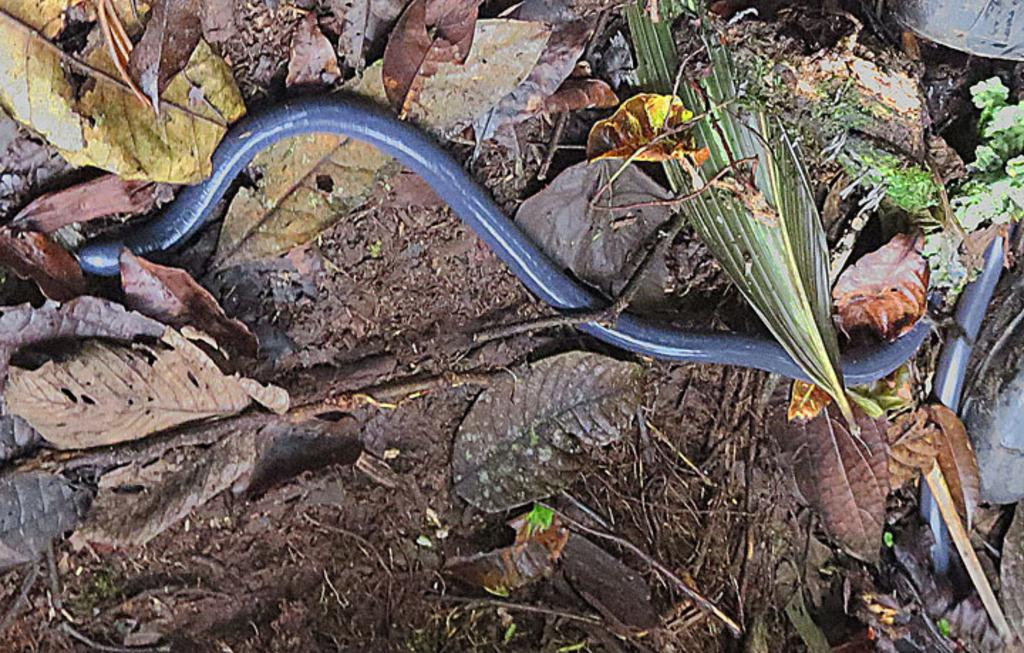What type of reptile is in the image? There is a legless lizard in the image. What can be seen in the background of the image? Leaves are present in the image. What is the temperature of the fifth lizard in the image? There is only one lizard present in the image, and it is legless, so there is no temperature or fifth lizard to consider. 